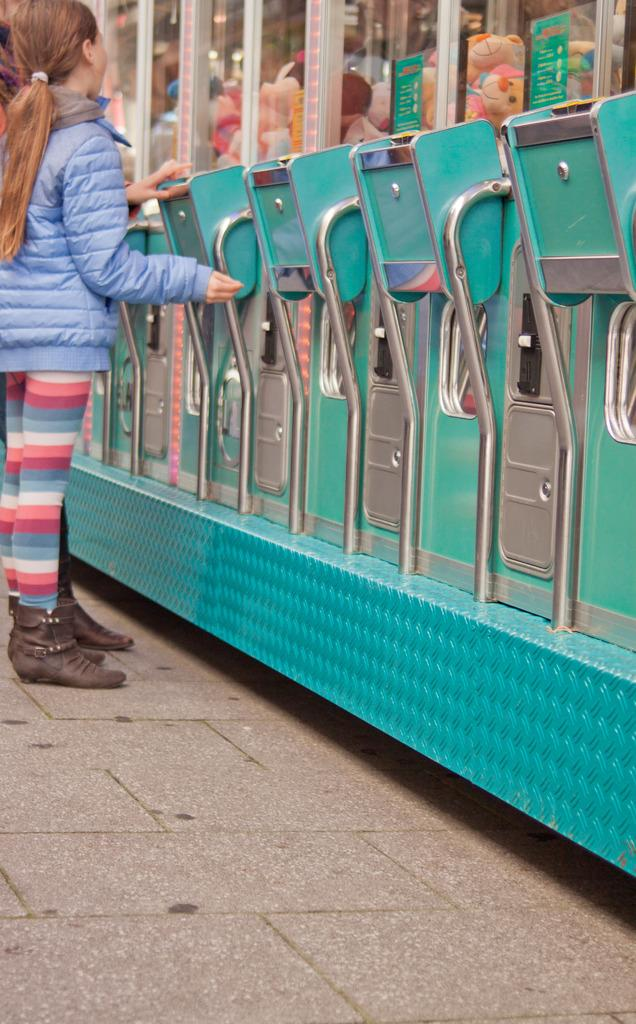Who is the main subject in the image? There is a girl in the image. What is the girl doing in the image? The girl is standing on the floor. What objects are in front of the girl? There are toy vending machines in front of the girl. What type of music is the girl playing on the support in the image? There is no support or music present in the image; it only features a girl standing in front of toy vending machines. 